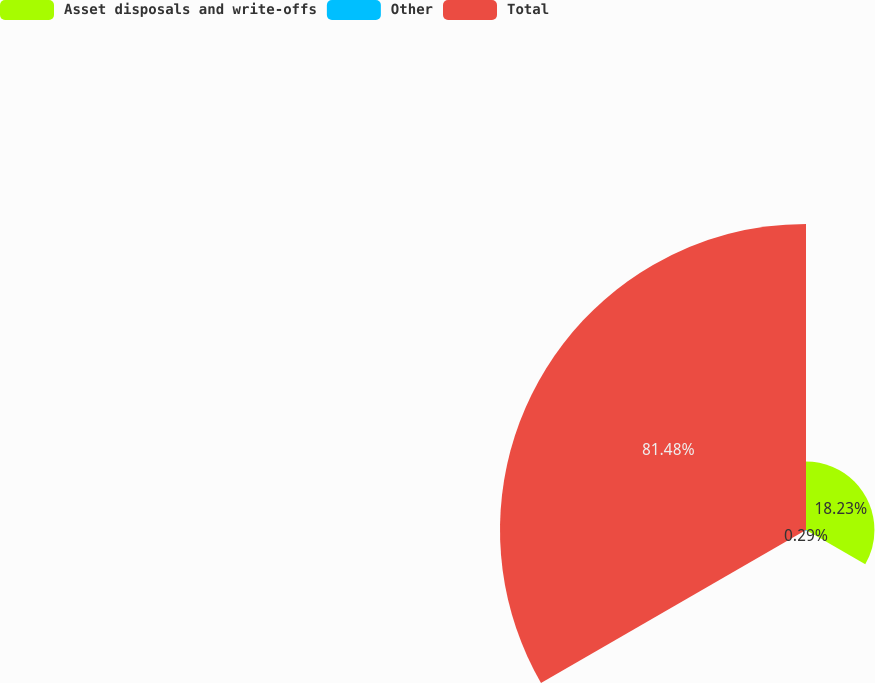<chart> <loc_0><loc_0><loc_500><loc_500><pie_chart><fcel>Asset disposals and write-offs<fcel>Other<fcel>Total<nl><fcel>18.23%<fcel>0.29%<fcel>81.49%<nl></chart> 